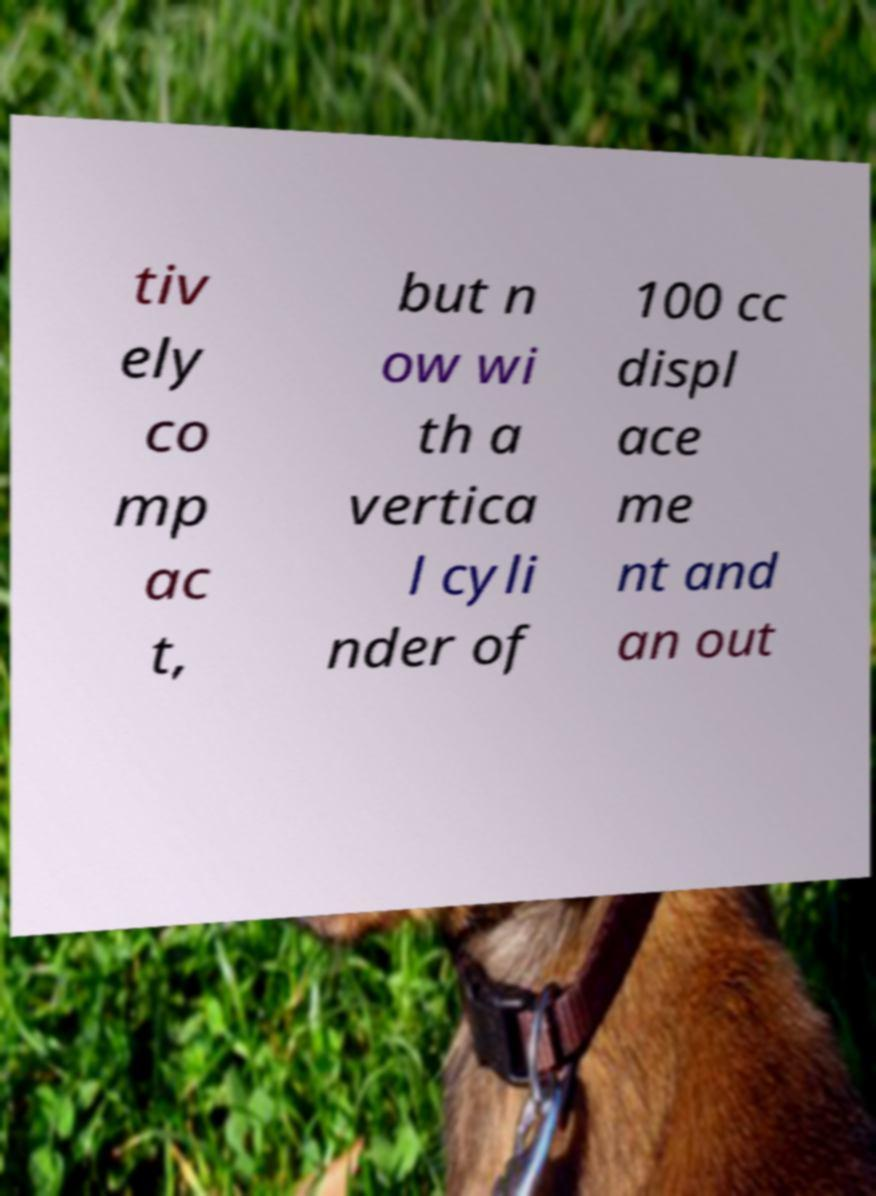Please identify and transcribe the text found in this image. tiv ely co mp ac t, but n ow wi th a vertica l cyli nder of 100 cc displ ace me nt and an out 